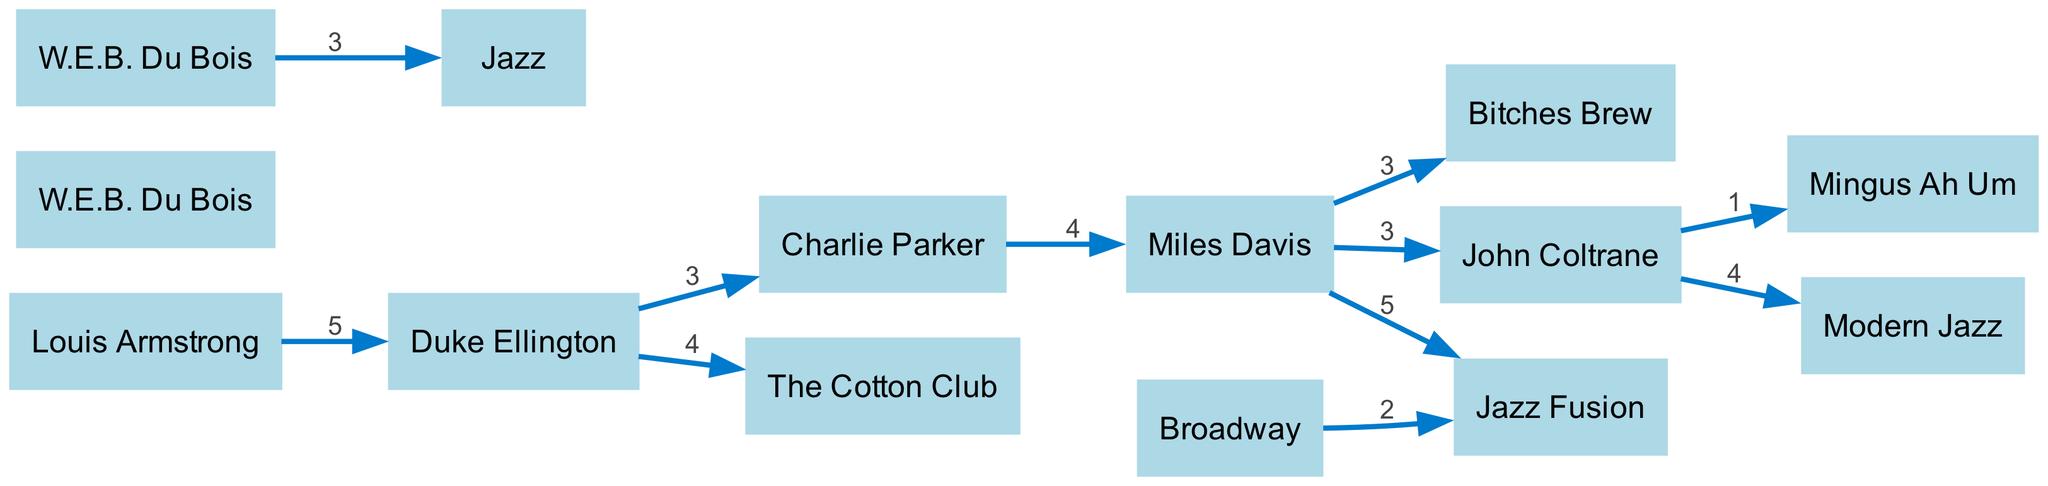What artist had the strongest influence on Jazz Fusion? The diagram shows a direct flow from Miles Davis to Jazz Fusion with a value of 5, indicating his strongest influence.
Answer: Miles Davis How many artists are directly connected to Duke Ellington? Analyzing the edges linked to Duke Ellington, there are three direct connections: The Cotton Club, Charlie Parker, and Louis Armstrong.
Answer: 3 Which artist connects Modern Jazz to the earlier jazz styles? The diagram indicates that John Coltrane connects to Modern Jazz, following a series of influences from earlier artists.
Answer: John Coltrane What is the total number of nodes in the diagram? Counting the unique entries in the nodes section, there are 11 nodes in total representing artists, genres, and performances.
Answer: 11 Which performance venue is linked to Duke Ellington and what is the value of this connection? The connection from Duke Ellington to The Cotton Club has a value of 4, representing a significant influence between them.
Answer: The Cotton Club (value 4) What did W.E.B. Du Bois influence in jazz? The diagram shows a link from W.E.B. Du Bois to Jazz, indicating his influence in this genre.
Answer: Jazz Which artist has connections to both Miles Davis and Modern Jazz? John Coltrane has links to both Miles Davis and Modern Jazz, illustrating his role in the evolution of these styles.
Answer: John Coltrane How many significant albums did Miles Davis influence according to this diagram? The links from Miles Davis show he influenced Bitches Brew and Jazz Fusion, totaling two significant albums.
Answer: 2 